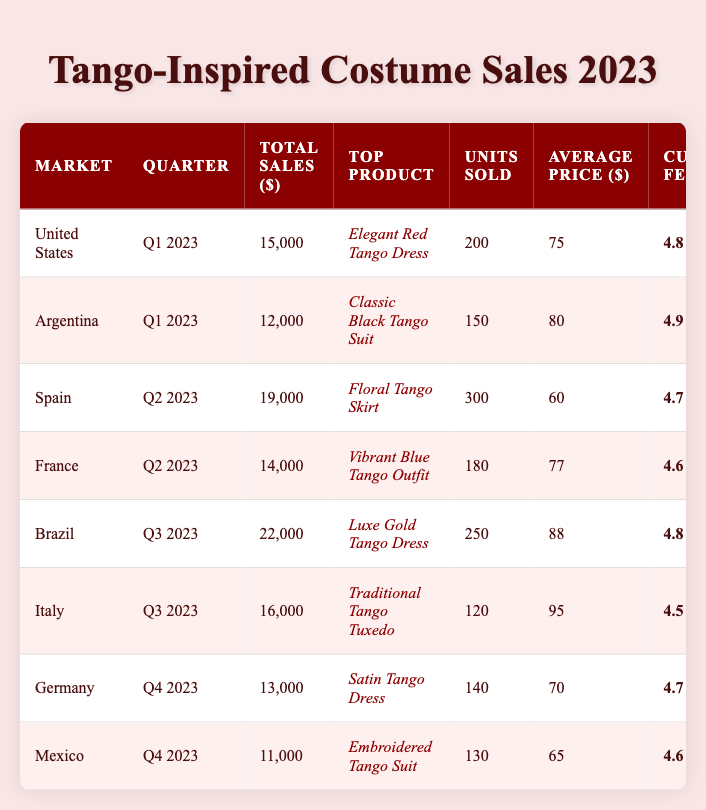What is the top-selling product in Brazil for Q3 2023? The table lists "Luxe Gold Tango Dress" as the top product for Brazil in Q3 2023.
Answer: Luxe Gold Tango Dress Which market had the highest customer feedback score, and what was that score? Argentina had the highest customer feedback score of 4.9.
Answer: Argentina, 4.9 What are the total sales in Spain for Q2 2023? The total sales in Spain for Q2 2023 are listed as $19,000.
Answer: 19,000 If we sum the total sales from all markets in Q4 2023, what amount do we get? The total sales in Q4 2023 are $13,000 (Germany) + $11,000 (Mexico) = $24,000.
Answer: 24,000 Is the average price of the top product sold in Italy higher than that in Germany? The average price in Italy is $95 for the Traditional Tango Tuxedo, and in Germany, it's $70 for the Satin Tango Dress, hence yes, it is higher.
Answer: Yes What is the average feedback score across all markets? The total feedback scores are 4.8 + 4.9 + 4.7 + 4.6 + 4.8 + 4.5 + 4.7 + 4.6 = 37.6. There are 8 markets, so the average is 37.6/8 = 4.7.
Answer: 4.7 How many total units were sold for the top product in the United States? The table shows that 200 units of the "Elegant Red Tango Dress" were sold in the United States.
Answer: 200 What product had the second lowest sales amount, and what were those sales? The second lowest sales amount is $11,000 for the "Embroidered Tango Suit" in Mexico.
Answer: Embroidered Tango Suit, 11,000 Which market sold the most units of their top product and how many units were sold? Spain sold the most units at 300 for the "Floral Tango Skirt."
Answer: Spain, 300 Can you find the difference in total sales between Brazil and Argentina? Brazil's total sales are $22,000, and Argentina's are $12,000, so the difference is $22,000 - $12,000 = $10,000.
Answer: 10,000 